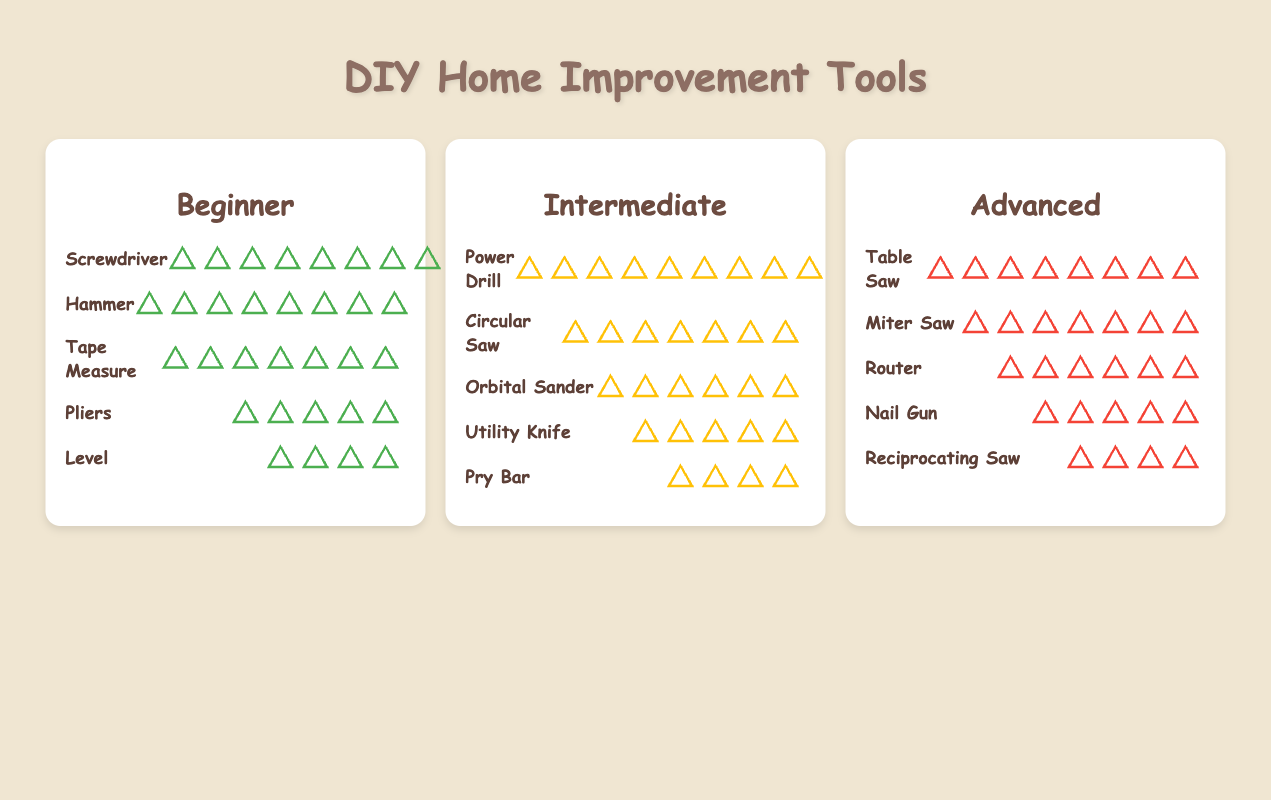What is the most common tool used by beginners in DIY home improvement? The most common tool for beginners can be identified by the highest count in the beginner section. The Screwdriver has 10 icons which represents the highest frequency.
Answer: Screwdriver Which skill level has the largest variety of tools? Count the number of different tools listed under each skill level. Beginner, Intermediate, and Advanced each have five different tools, so they all have the same variety.
Answer: All levels How many more tools are represented by a Power Drill compared to a Reciprocating Saw? The Power Drill appears under Intermediate with 9 icons, and the Reciprocating Saw appears under Advanced with 4 icons. The difference is 9 - 4 = 5.
Answer: 5 Which tool is equally common among both Intermediate and Advanced skill levels? Look for a tool with the same count in both Intermediate and Advanced tool lists. The Circular Saw has 7 icons in Intermediate, and the Miter Saw in Advanced also has 7 icons, but they are different tools. Therefore, there is no shared tool with the same count.
Answer: None Which skill level's tools collectively sum to the highest count? Add the counts for each skill level:
Beginner: 10 + 8 + 7 + 5 + 4 = 34
Intermediate: 9 + 7 + 6 + 5 + 4 = 31
Advanced: 8 + 7 + 6 + 5 + 4 = 30
The highest sum is for Beginner with a total of 34.
Answer: Beginner What is the total number of tools represented in the plot? Summing all the listed counts for each skill level:
Beginner: 10 + 8 + 7 + 5 + 4 = 34
Intermediate: 9 + 7 + 6 + 5 + 4 = 31
Advanced: 8 + 7 + 6 + 5 + 4 = 30
Total: 34 + 31 + 30 = 95
Answer: 95 Which tools appear under the Advanced skill level with the same count? Examine the counts for tools under Advanced:
Router and Orbital Sander both have 6 icons, so these two tools have the same count.
Answer: Router and Orbital Sander Which is more common: a Hammer among Beginners or a Table Saw among Advanced users? Count the icons for Hammer under Beginner (8 icons) and compare it to Table Saw under Advanced (8 icons). They are equally common.
Answer: Same What is the least common tool for each skill level? Identify the tool with the lowest count in each skill level:
Beginner: Level (4)
Intermediate: Pry Bar (4)
Advanced: Reciprocating Saw (4)
All skill levels have a tool with a count of 4, so there are multiple least common tools.
Answer: Level, Pry Bar, Reciprocating Saw What is the sum of tools used in Intermediate and Advanced skill levels? Sum the total counts for Intermediate and Advanced:
Intermediate: 9 + 7 + 6 + 5 + 4 = 31
Advanced: 8 + 7 + 6 + 5 + 4 = 30
Total: 31 + 30 = 61
Answer: 61 